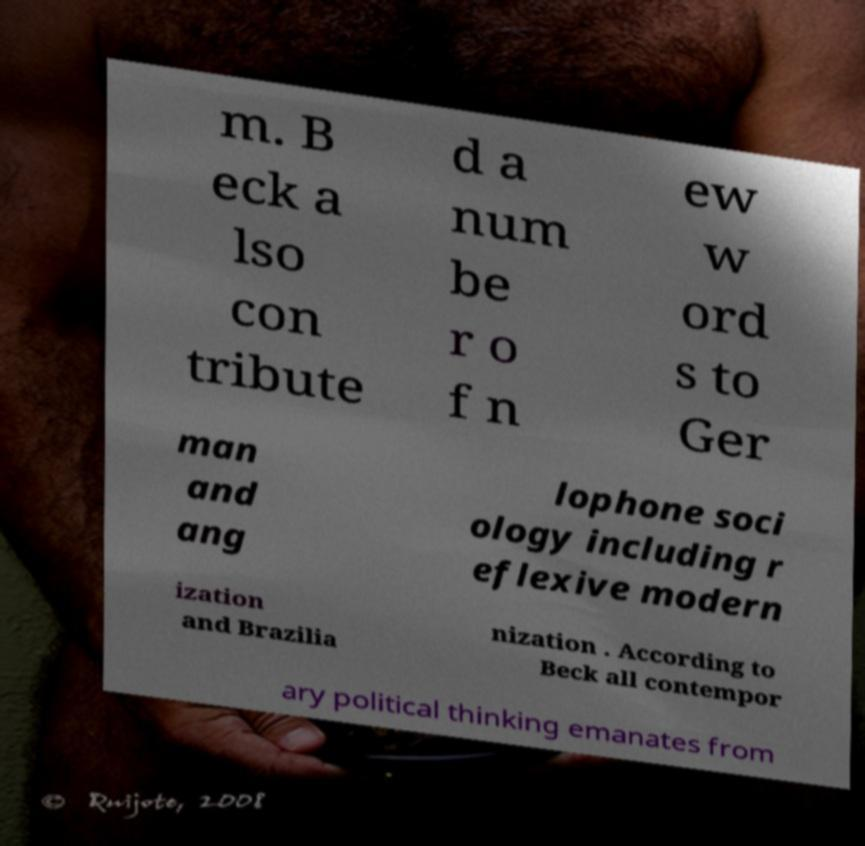What messages or text are displayed in this image? I need them in a readable, typed format. m. B eck a lso con tribute d a num be r o f n ew w ord s to Ger man and ang lophone soci ology including r eflexive modern ization and Brazilia nization . According to Beck all contempor ary political thinking emanates from 